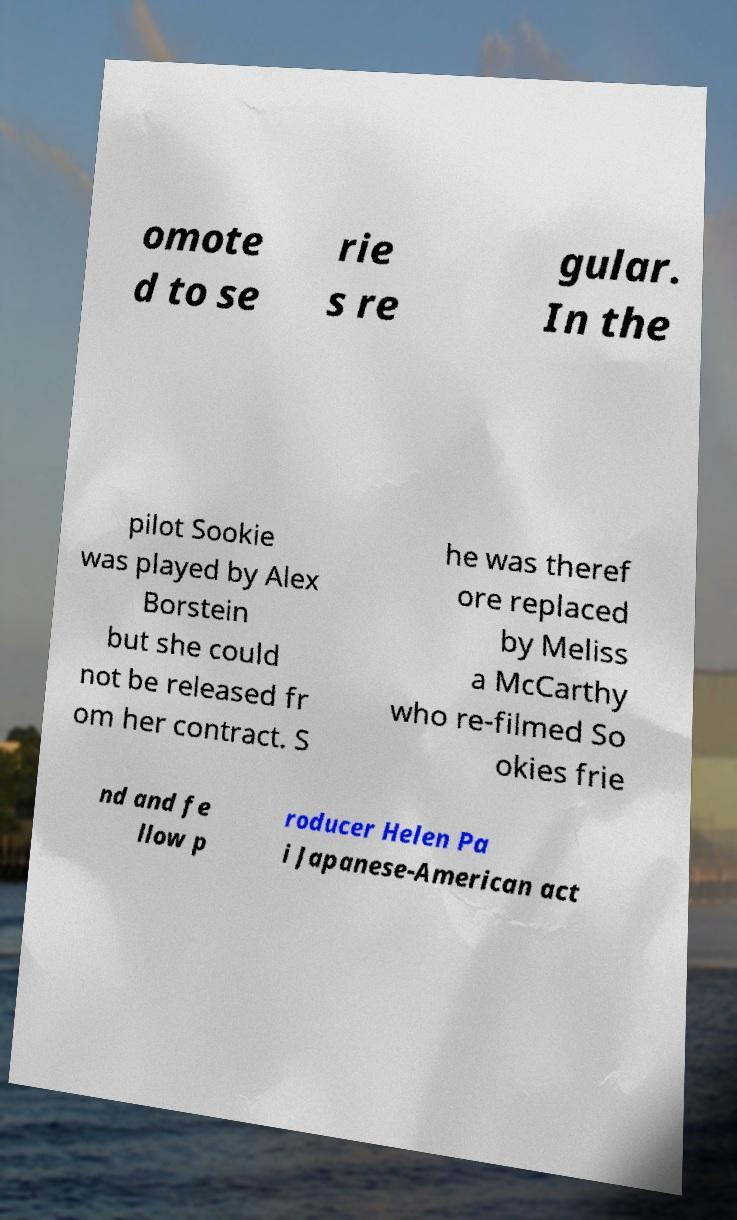Please read and relay the text visible in this image. What does it say? omote d to se rie s re gular. In the pilot Sookie was played by Alex Borstein but she could not be released fr om her contract. S he was theref ore replaced by Meliss a McCarthy who re-filmed So okies frie nd and fe llow p roducer Helen Pa i Japanese-American act 